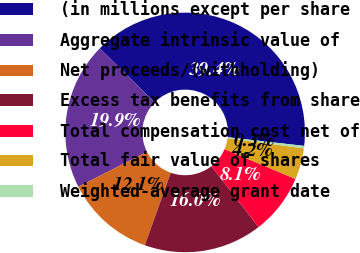<chart> <loc_0><loc_0><loc_500><loc_500><pie_chart><fcel>(in millions except per share<fcel>Aggregate intrinsic value of<fcel>Net proceeds/(withholding)<fcel>Excess tax benefits from share<fcel>Total compensation cost net of<fcel>Total fair value of shares<fcel>Weighted-average grant date<nl><fcel>39.41%<fcel>19.87%<fcel>12.05%<fcel>15.96%<fcel>8.14%<fcel>4.23%<fcel>0.33%<nl></chart> 